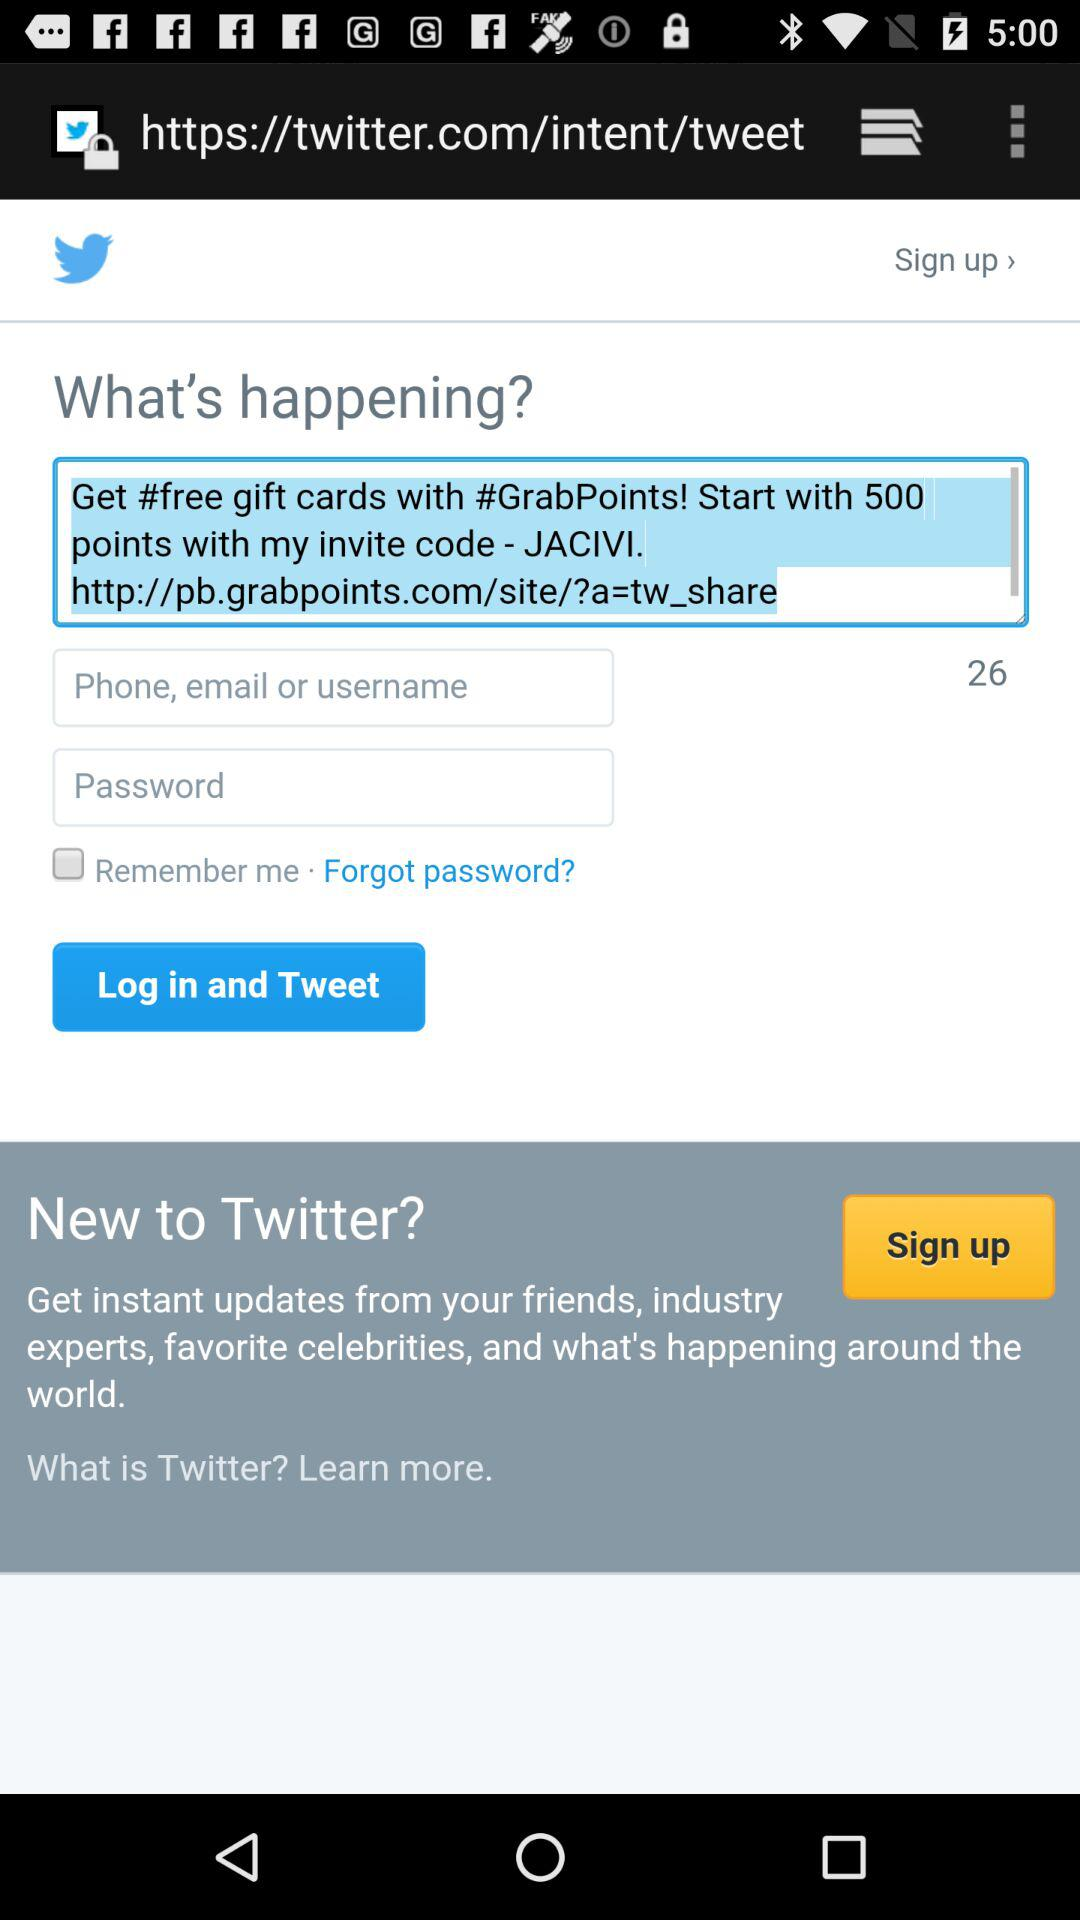What is the invite code? The invite code is "JACIVI". 